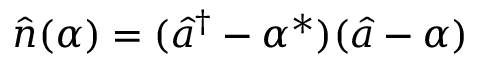Convert formula to latex. <formula><loc_0><loc_0><loc_500><loc_500>\hat { n } ( \alpha ) = ( \hat { a } ^ { \dag } - \alpha ^ { \ast } ) ( \hat { a } - \alpha )</formula> 